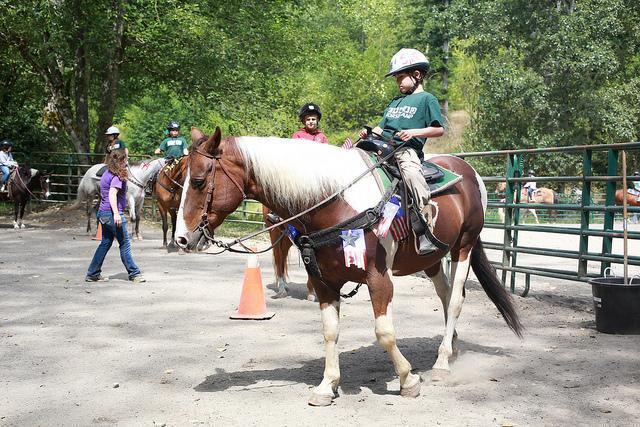How many horses are in the picture?
Give a very brief answer. 3. How many people are there?
Give a very brief answer. 2. How many baby giraffes are there?
Give a very brief answer. 0. 